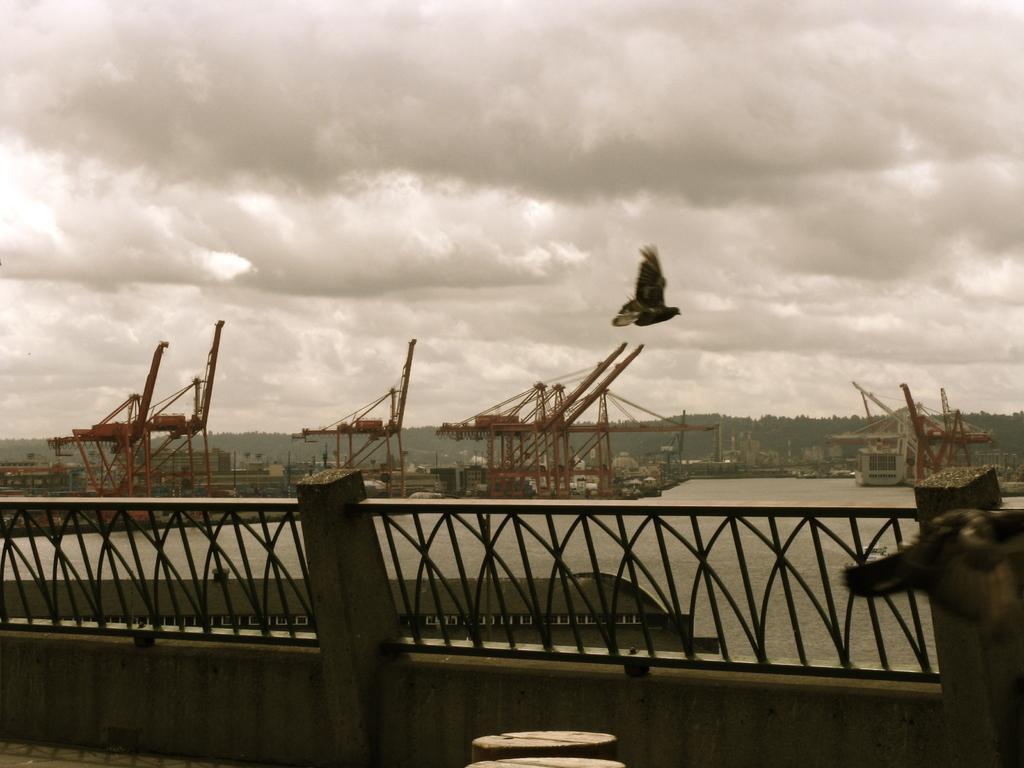Can you describe this image briefly? In this picture we can see river and this is the fence. And on the background there are many trees. This is the bird. And there is a sky with heavy clouds. 